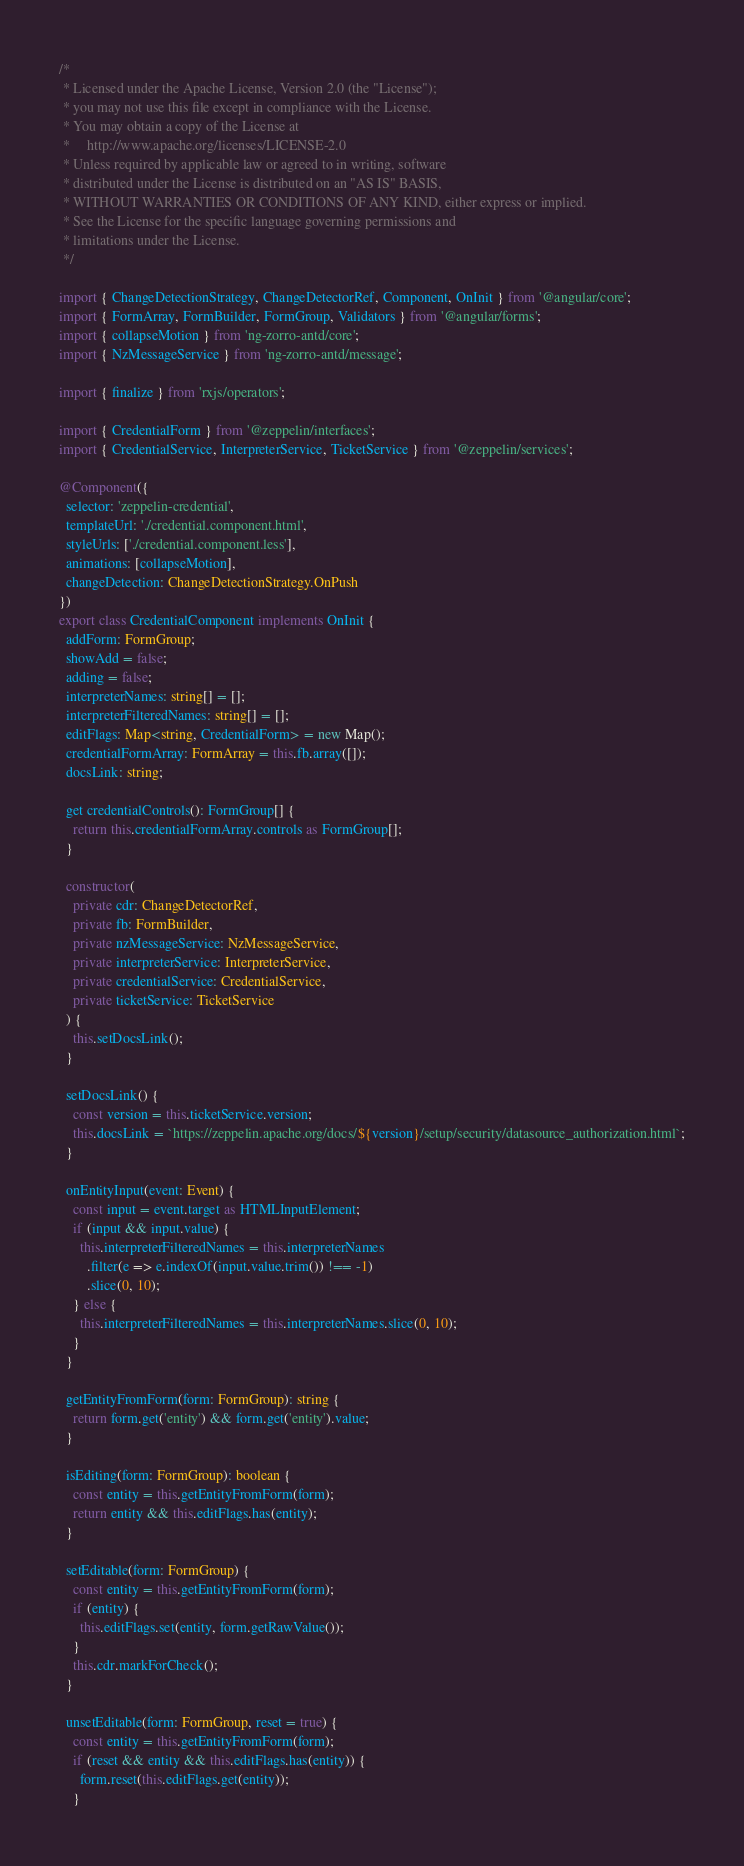<code> <loc_0><loc_0><loc_500><loc_500><_TypeScript_>/*
 * Licensed under the Apache License, Version 2.0 (the "License");
 * you may not use this file except in compliance with the License.
 * You may obtain a copy of the License at
 *     http://www.apache.org/licenses/LICENSE-2.0
 * Unless required by applicable law or agreed to in writing, software
 * distributed under the License is distributed on an "AS IS" BASIS,
 * WITHOUT WARRANTIES OR CONDITIONS OF ANY KIND, either express or implied.
 * See the License for the specific language governing permissions and
 * limitations under the License.
 */

import { ChangeDetectionStrategy, ChangeDetectorRef, Component, OnInit } from '@angular/core';
import { FormArray, FormBuilder, FormGroup, Validators } from '@angular/forms';
import { collapseMotion } from 'ng-zorro-antd/core';
import { NzMessageService } from 'ng-zorro-antd/message';

import { finalize } from 'rxjs/operators';

import { CredentialForm } from '@zeppelin/interfaces';
import { CredentialService, InterpreterService, TicketService } from '@zeppelin/services';

@Component({
  selector: 'zeppelin-credential',
  templateUrl: './credential.component.html',
  styleUrls: ['./credential.component.less'],
  animations: [collapseMotion],
  changeDetection: ChangeDetectionStrategy.OnPush
})
export class CredentialComponent implements OnInit {
  addForm: FormGroup;
  showAdd = false;
  adding = false;
  interpreterNames: string[] = [];
  interpreterFilteredNames: string[] = [];
  editFlags: Map<string, CredentialForm> = new Map();
  credentialFormArray: FormArray = this.fb.array([]);
  docsLink: string;

  get credentialControls(): FormGroup[] {
    return this.credentialFormArray.controls as FormGroup[];
  }

  constructor(
    private cdr: ChangeDetectorRef,
    private fb: FormBuilder,
    private nzMessageService: NzMessageService,
    private interpreterService: InterpreterService,
    private credentialService: CredentialService,
    private ticketService: TicketService
  ) {
    this.setDocsLink();
  }

  setDocsLink() {
    const version = this.ticketService.version;
    this.docsLink = `https://zeppelin.apache.org/docs/${version}/setup/security/datasource_authorization.html`;
  }

  onEntityInput(event: Event) {
    const input = event.target as HTMLInputElement;
    if (input && input.value) {
      this.interpreterFilteredNames = this.interpreterNames
        .filter(e => e.indexOf(input.value.trim()) !== -1)
        .slice(0, 10);
    } else {
      this.interpreterFilteredNames = this.interpreterNames.slice(0, 10);
    }
  }

  getEntityFromForm(form: FormGroup): string {
    return form.get('entity') && form.get('entity').value;
  }

  isEditing(form: FormGroup): boolean {
    const entity = this.getEntityFromForm(form);
    return entity && this.editFlags.has(entity);
  }

  setEditable(form: FormGroup) {
    const entity = this.getEntityFromForm(form);
    if (entity) {
      this.editFlags.set(entity, form.getRawValue());
    }
    this.cdr.markForCheck();
  }

  unsetEditable(form: FormGroup, reset = true) {
    const entity = this.getEntityFromForm(form);
    if (reset && entity && this.editFlags.has(entity)) {
      form.reset(this.editFlags.get(entity));
    }</code> 